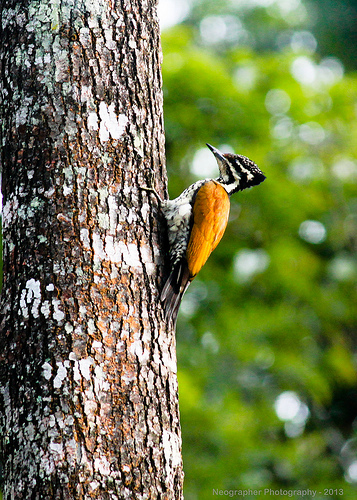Please provide the bounding box coordinate of the region this sentence describes: the stripes of a bird. The defined coordinates [0.58, 0.33, 0.64, 0.38] accurately capture the area where the bird's distinctive black and white stripes are prominent along its side. 